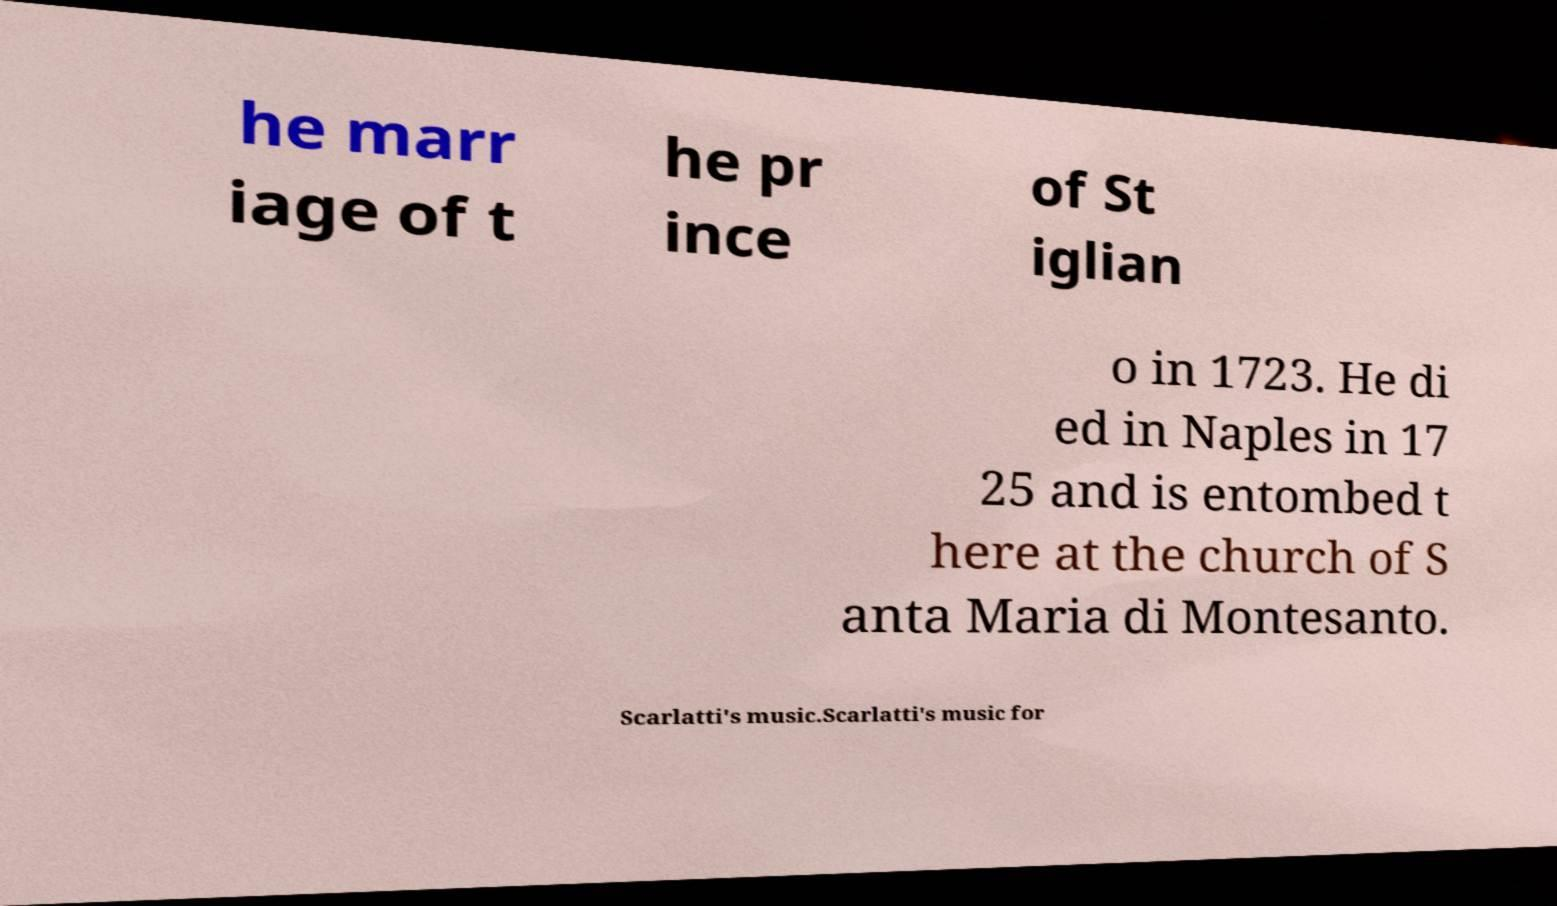For documentation purposes, I need the text within this image transcribed. Could you provide that? he marr iage of t he pr ince of St iglian o in 1723. He di ed in Naples in 17 25 and is entombed t here at the church of S anta Maria di Montesanto. Scarlatti's music.Scarlatti's music for 